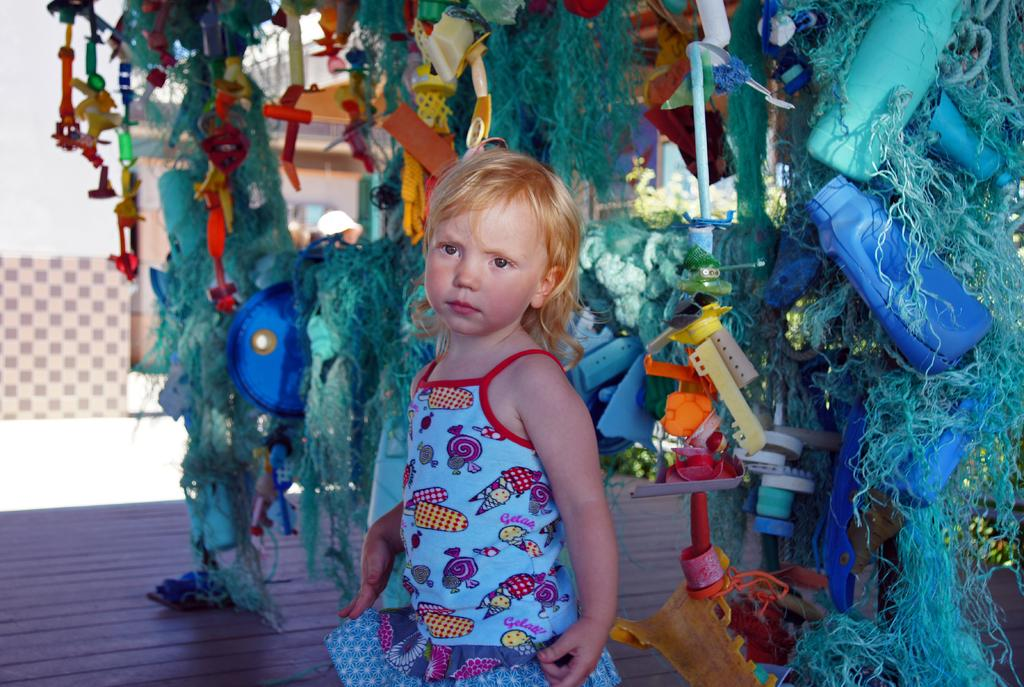What is the main subject of the image? There is a child in the image. Where is the child located in the image? The child is standing on the floor. What can be observed happening in the background of the image? Things are changing in the background of the image. What type of decorative material is present in the image? Decoration papers are present in the image. What is the child's tendency to walk in the image? The image does not provide information about the child's tendency to walk. 